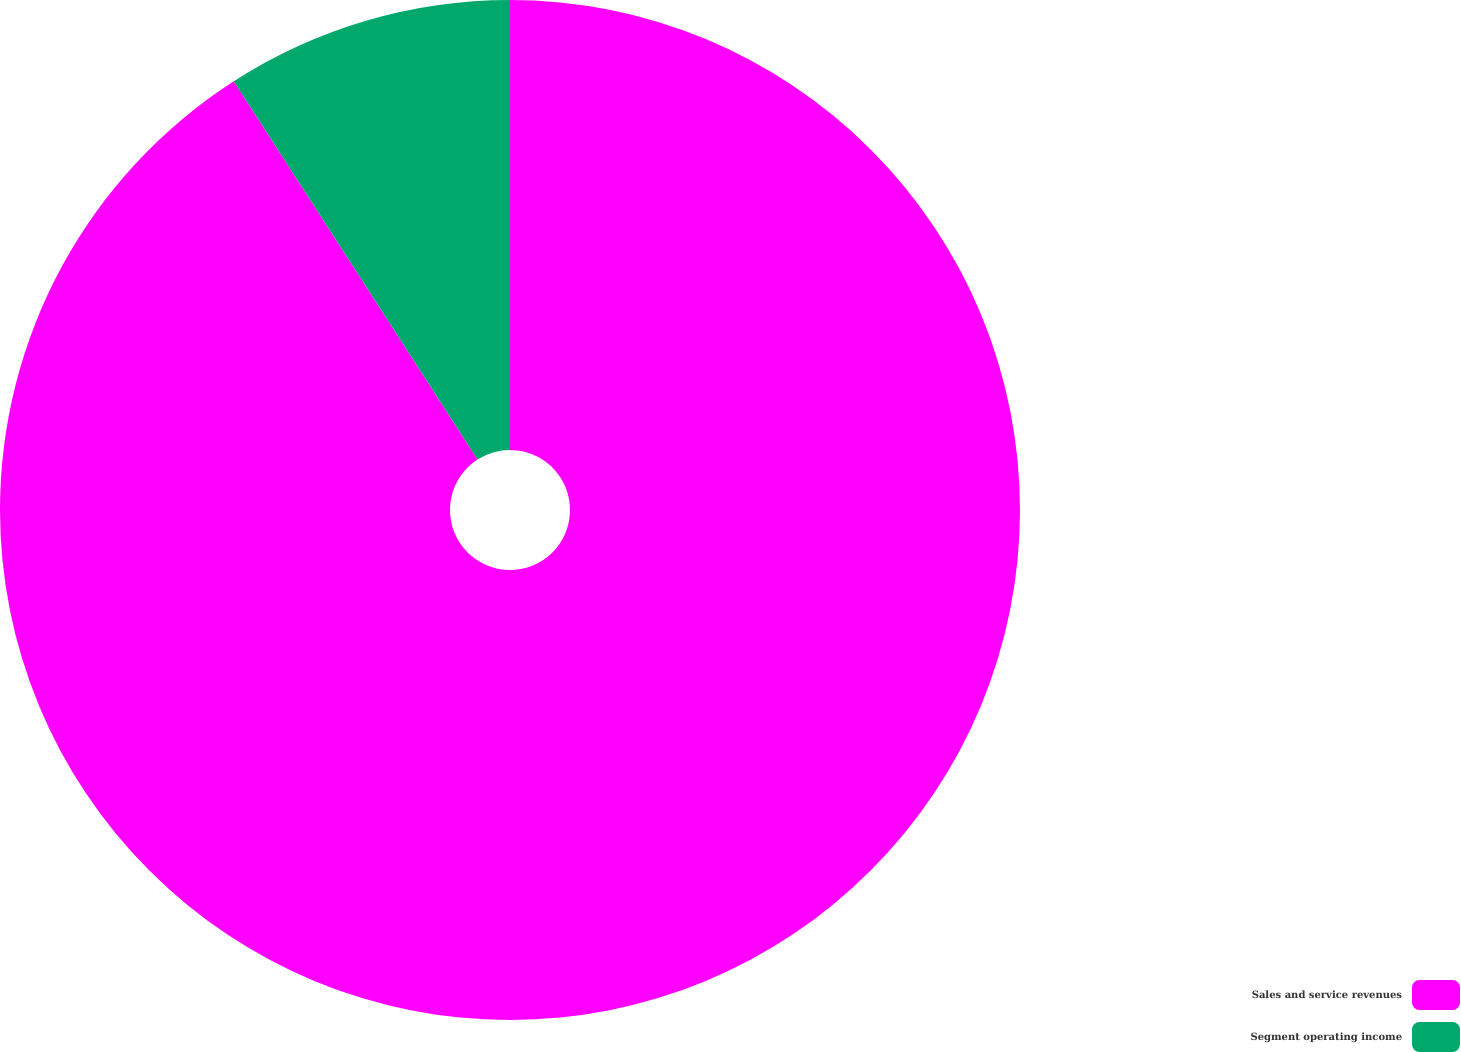Convert chart. <chart><loc_0><loc_0><loc_500><loc_500><pie_chart><fcel>Sales and service revenues<fcel>Segment operating income<nl><fcel>90.89%<fcel>9.11%<nl></chart> 